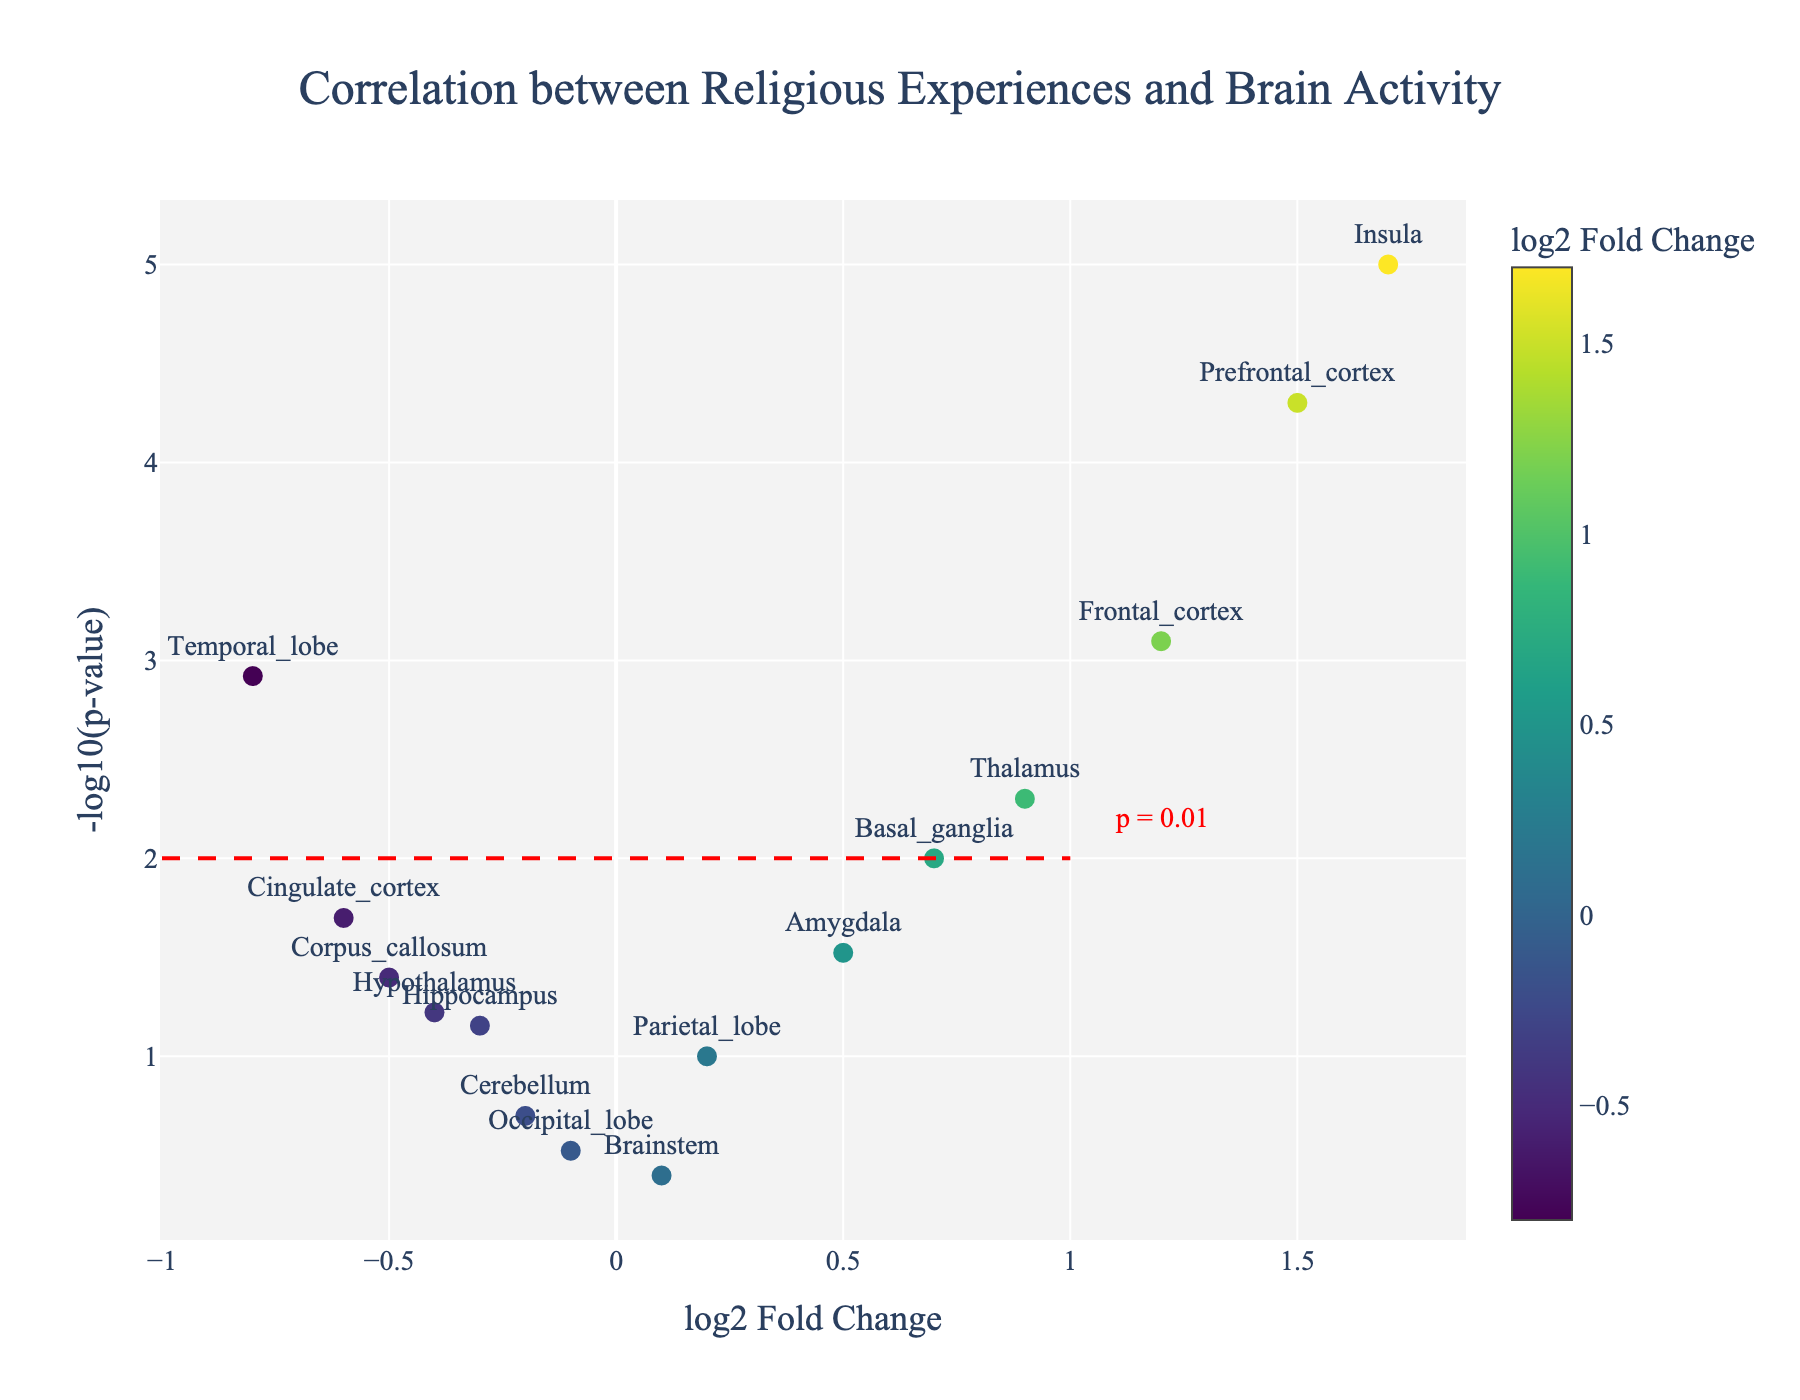What is the title of the figure? The title is usually displayed prominently at the top of the figure. The title here reads, "Correlation between Religious Experiences and Brain Activity".
Answer: Correlation between Religious Experiences and Brain Activity What does the x-axis represent in the figure? Looking at the label on the x-axis, it is mentioned as "log2 Fold Change". This indicates that the x-axis represents the change in brain activity, measured on a logarithmic scale base 2.
Answer: log2 Fold Change Which brain region has the highest log2 Fold Change? By examining the x-axis values, the Prefrontal_cortex is the farthest to the right with a log2 Fold Change of 1.5.
Answer: Prefrontal_cortex Which brain region has the lowest p-value? The lowest p-value can be identified by the highest y-value on the y-axis, representing -log10(p-value). The Insula, which is positioned highest on the y-axis, has the lowest p-value of 0.00001.
Answer: Insula How many brain regions have a p-value less than 0.01? Data points above the y=2 line (as -log10(0.01) = 2) represent p-values less than 0.01. These regions are the Frontal_cortex, Insula, Prefrontal_cortex, and Thalamus. So, there are 4 such brain regions.
Answer: 4 Which region shows a negative log2 Fold Change but has a significant p-value (less than 0.05)? We need to find a data point with a negative x-value but having a y-value greater than 1.3 (as -log10(0.05) ≈ 1.3). The regions are Temporal_lobe, Cingulate_cortex, and Corpus_callosum.
Answer: Temporal_lobe, Cingulate_cortex, Corpus_callosum Compare and contrast the log2 Fold Change of Amygdala and Basal_ganglia. Which has a higher value, and by how much? The log2 Fold Change of Amygdala is 0.5, and for Basal_ganglia is 0.7. Basal_ganglia's log2 Fold Change is higher by 0.2.
Answer: Basal_ganglia is higher by 0.2 What is the significance threshold depicted in the plot? The significance threshold is represented by the red dashed line, marked at y=2, indicating the significance level is p=0.01.
Answer: p=0.01 Which data point is closest to the threshold of significance line and lies on the positive side of the log2 Fold Change axis? For this, we look at points just above the y=2 line on the right of x=0. The Thalamus is closest to the threshold line on the positive side.
Answer: Thalamus 